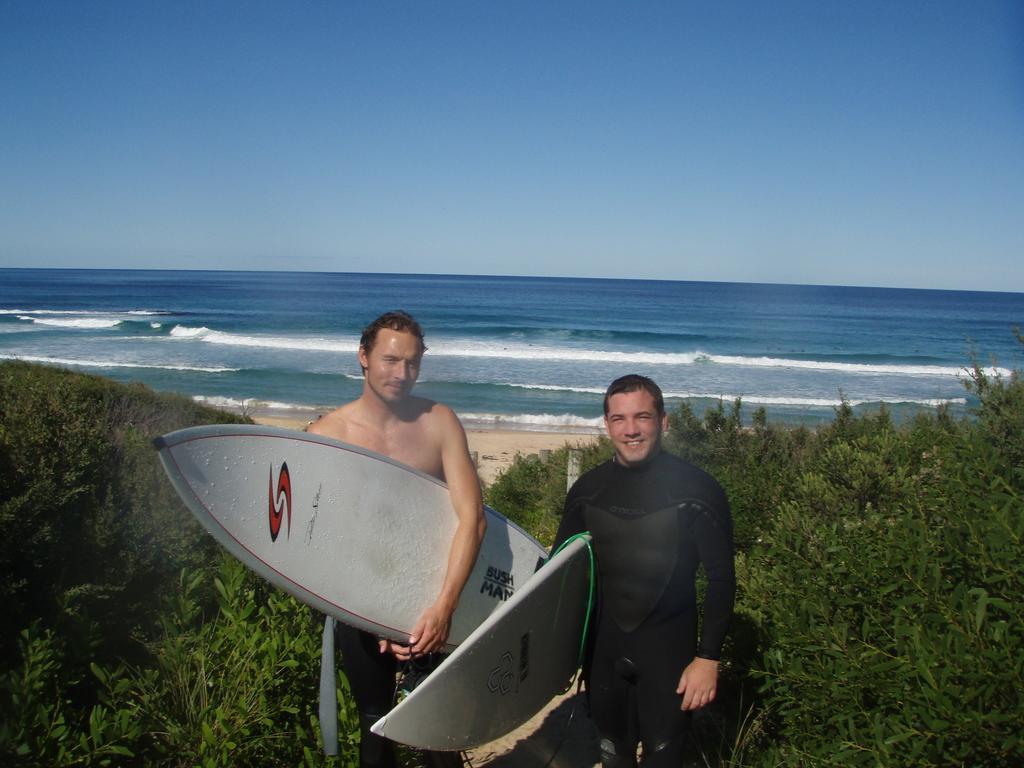Could you give a brief overview of what you see in this image? In the image we can see there are lot of greenery and on the other side there is a beach and there is a sea and in front there are two men who are holding surfing boards. 